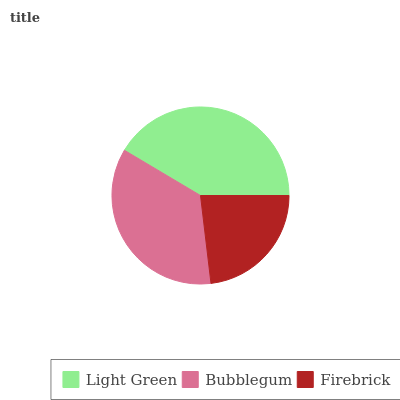Is Firebrick the minimum?
Answer yes or no. Yes. Is Light Green the maximum?
Answer yes or no. Yes. Is Bubblegum the minimum?
Answer yes or no. No. Is Bubblegum the maximum?
Answer yes or no. No. Is Light Green greater than Bubblegum?
Answer yes or no. Yes. Is Bubblegum less than Light Green?
Answer yes or no. Yes. Is Bubblegum greater than Light Green?
Answer yes or no. No. Is Light Green less than Bubblegum?
Answer yes or no. No. Is Bubblegum the high median?
Answer yes or no. Yes. Is Bubblegum the low median?
Answer yes or no. Yes. Is Firebrick the high median?
Answer yes or no. No. Is Firebrick the low median?
Answer yes or no. No. 